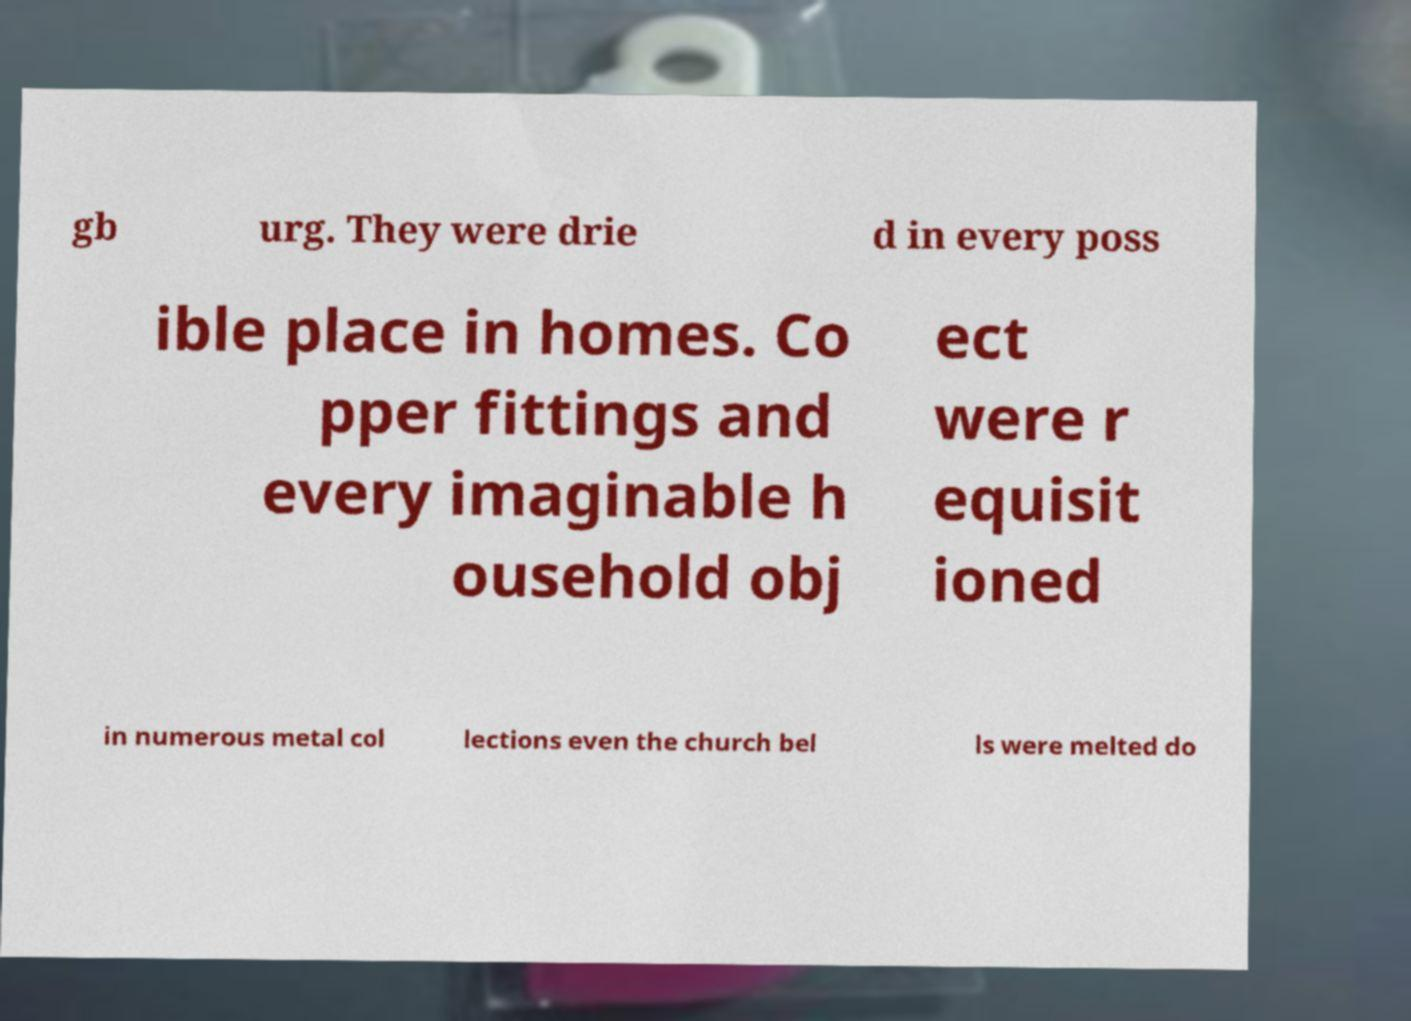There's text embedded in this image that I need extracted. Can you transcribe it verbatim? gb urg. They were drie d in every poss ible place in homes. Co pper fittings and every imaginable h ousehold obj ect were r equisit ioned in numerous metal col lections even the church bel ls were melted do 